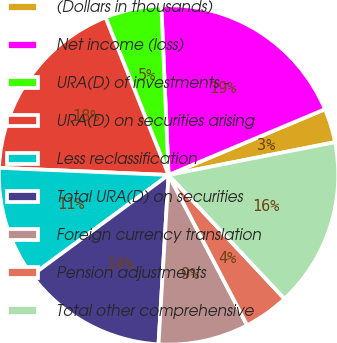Convert chart to OTSL. <chart><loc_0><loc_0><loc_500><loc_500><pie_chart><fcel>(Dollars in thousands)<fcel>Net income (loss)<fcel>URA(D) of investments -<fcel>URA(D) on securities arising<fcel>Less reclassification<fcel>Total URA(D) on securities<fcel>Foreign currency translation<fcel>Pension adjustments<fcel>Total other comprehensive<nl><fcel>3.24%<fcel>19.34%<fcel>5.38%<fcel>18.27%<fcel>10.75%<fcel>13.97%<fcel>8.61%<fcel>4.31%<fcel>16.12%<nl></chart> 